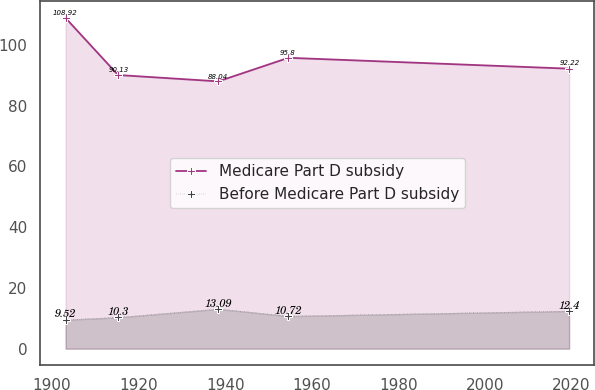Convert chart to OTSL. <chart><loc_0><loc_0><loc_500><loc_500><line_chart><ecel><fcel>Medicare Part D subsidy<fcel>Before Medicare Part D subsidy<nl><fcel>1903.12<fcel>108.92<fcel>9.52<nl><fcel>1915.25<fcel>90.13<fcel>10.3<nl><fcel>1938.4<fcel>88.04<fcel>13.09<nl><fcel>1954.61<fcel>95.8<fcel>10.72<nl><fcel>2019.43<fcel>92.22<fcel>12.4<nl></chart> 